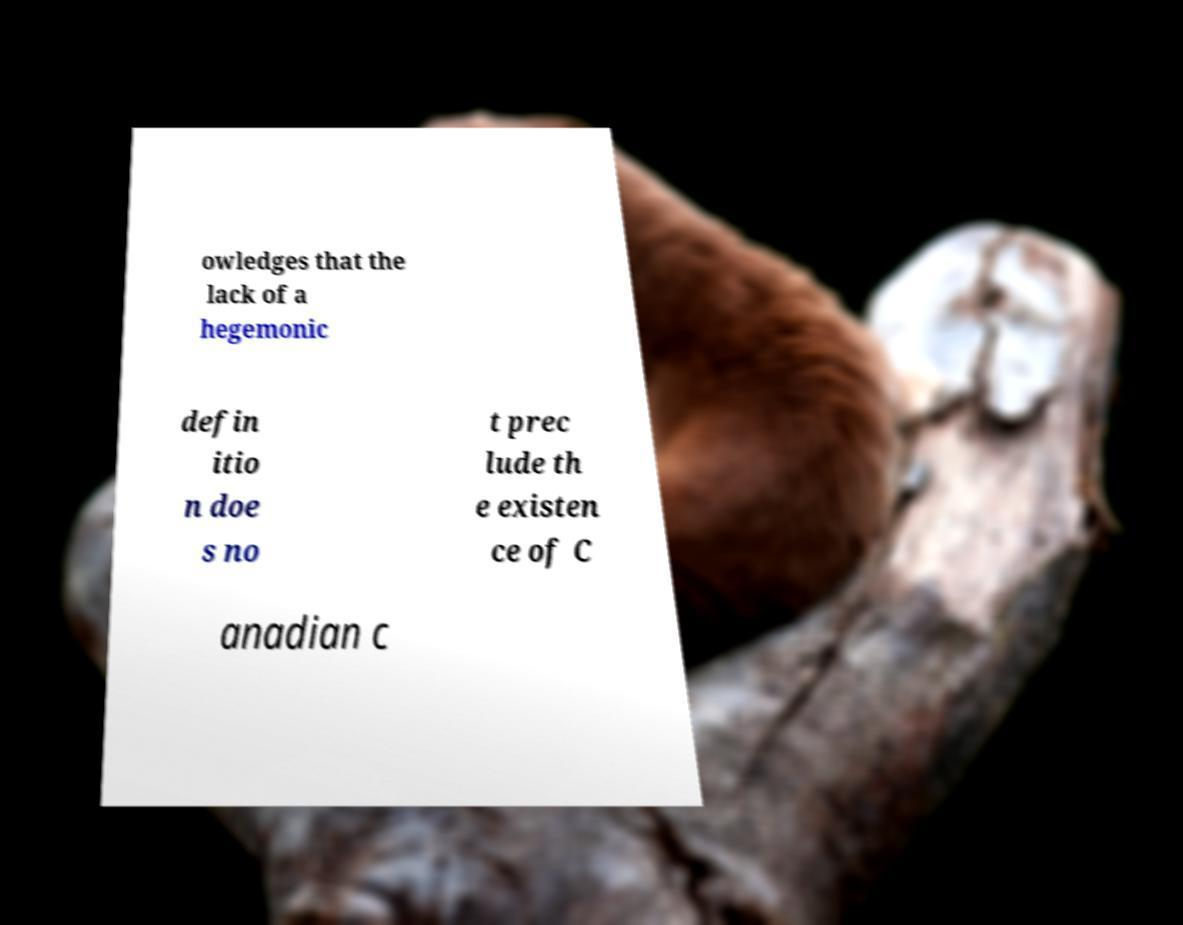For documentation purposes, I need the text within this image transcribed. Could you provide that? owledges that the lack of a hegemonic defin itio n doe s no t prec lude th e existen ce of C anadian c 